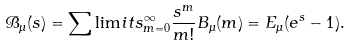Convert formula to latex. <formula><loc_0><loc_0><loc_500><loc_500>\mathcal { B } _ { \mu } ( s ) = \sum \lim i t s _ { m = 0 } ^ { \infty } \frac { s ^ { m } } { m ! } B _ { \mu } ( m ) = E _ { \mu } ( e ^ { s } - 1 ) .</formula> 